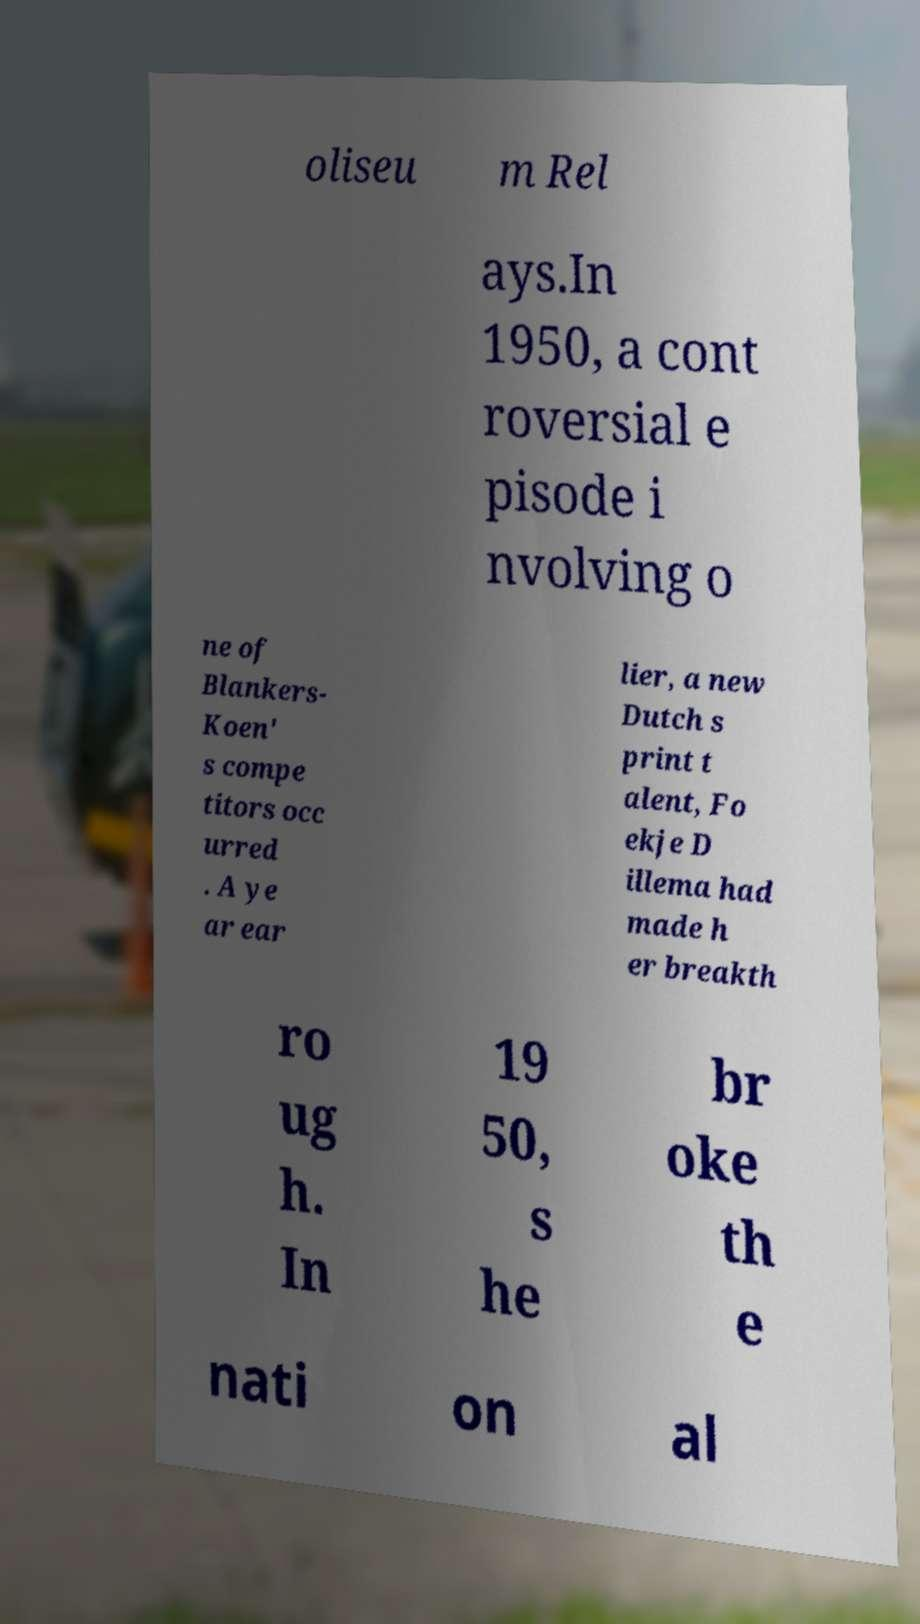Could you assist in decoding the text presented in this image and type it out clearly? oliseu m Rel ays.In 1950, a cont roversial e pisode i nvolving o ne of Blankers- Koen' s compe titors occ urred . A ye ar ear lier, a new Dutch s print t alent, Fo ekje D illema had made h er breakth ro ug h. In 19 50, s he br oke th e nati on al 